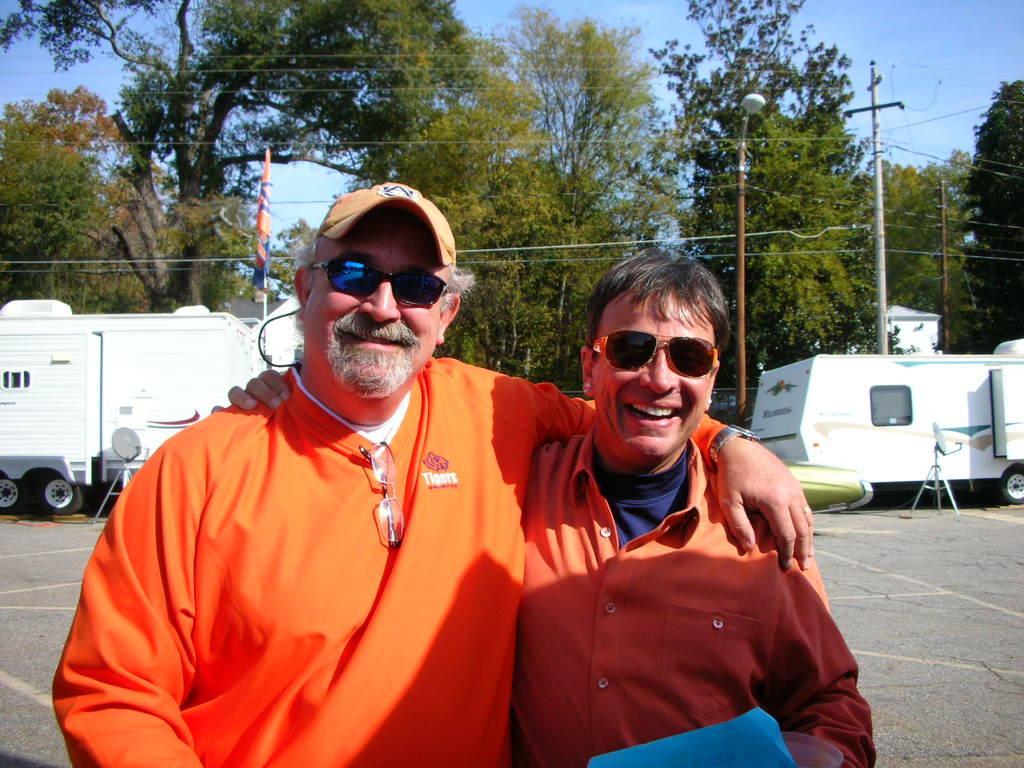Please provide a concise description of this image. The picture is taken outside a city. In the foreground of the picture there are two men wearing orange shirts. In the center of the picture there are trees, vehicles, street light, pole and cables. Sky is clear and it is sunny. 